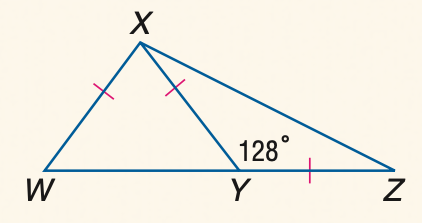Answer the mathemtical geometry problem and directly provide the correct option letter.
Question: \triangle W X Y and \triangle X Y Z are isosceles and m \angle X Y Z = 128. Find the measure of \angle W X Y.
Choices: A: 72 B: 74 C: 76 D: 78 C 